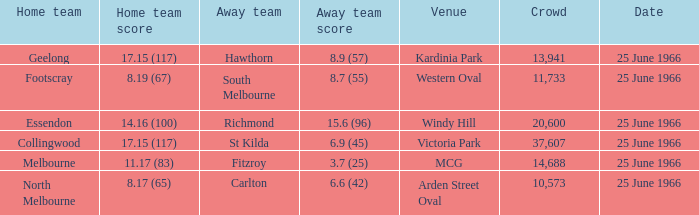Parse the table in full. {'header': ['Home team', 'Home team score', 'Away team', 'Away team score', 'Venue', 'Crowd', 'Date'], 'rows': [['Geelong', '17.15 (117)', 'Hawthorn', '8.9 (57)', 'Kardinia Park', '13,941', '25 June 1966'], ['Footscray', '8.19 (67)', 'South Melbourne', '8.7 (55)', 'Western Oval', '11,733', '25 June 1966'], ['Essendon', '14.16 (100)', 'Richmond', '15.6 (96)', 'Windy Hill', '20,600', '25 June 1966'], ['Collingwood', '17.15 (117)', 'St Kilda', '6.9 (45)', 'Victoria Park', '37,607', '25 June 1966'], ['Melbourne', '11.17 (83)', 'Fitzroy', '3.7 (25)', 'MCG', '14,688', '25 June 1966'], ['North Melbourne', '8.17 (65)', 'Carlton', '6.6 (42)', 'Arden Street Oval', '10,573', '25 June 1966']]} At what location did the away team reach Western Oval. 